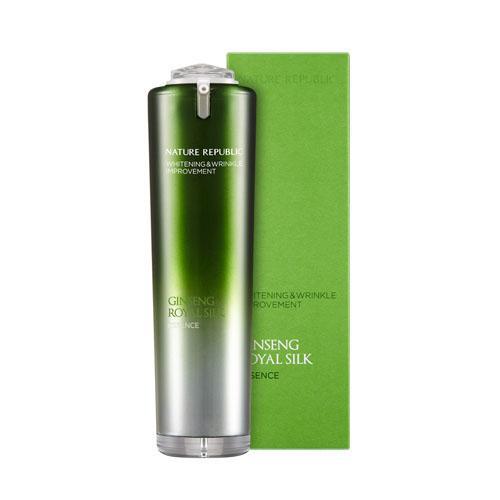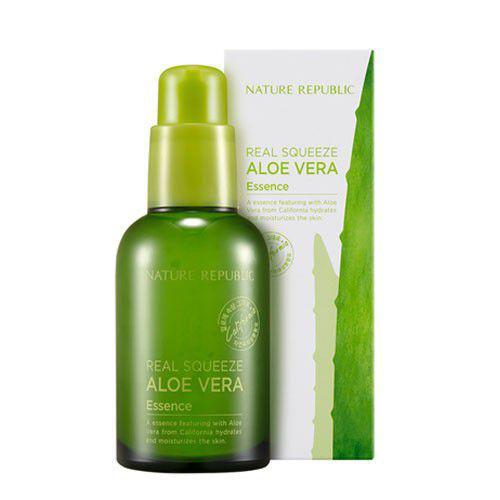The first image is the image on the left, the second image is the image on the right. Examine the images to the left and right. Is the description "There are two products in total in the pair of images." accurate? Answer yes or no. Yes. The first image is the image on the left, the second image is the image on the right. Considering the images on both sides, is "An image includes just one product next to a box: a green bottle without a white label." valid? Answer yes or no. Yes. 